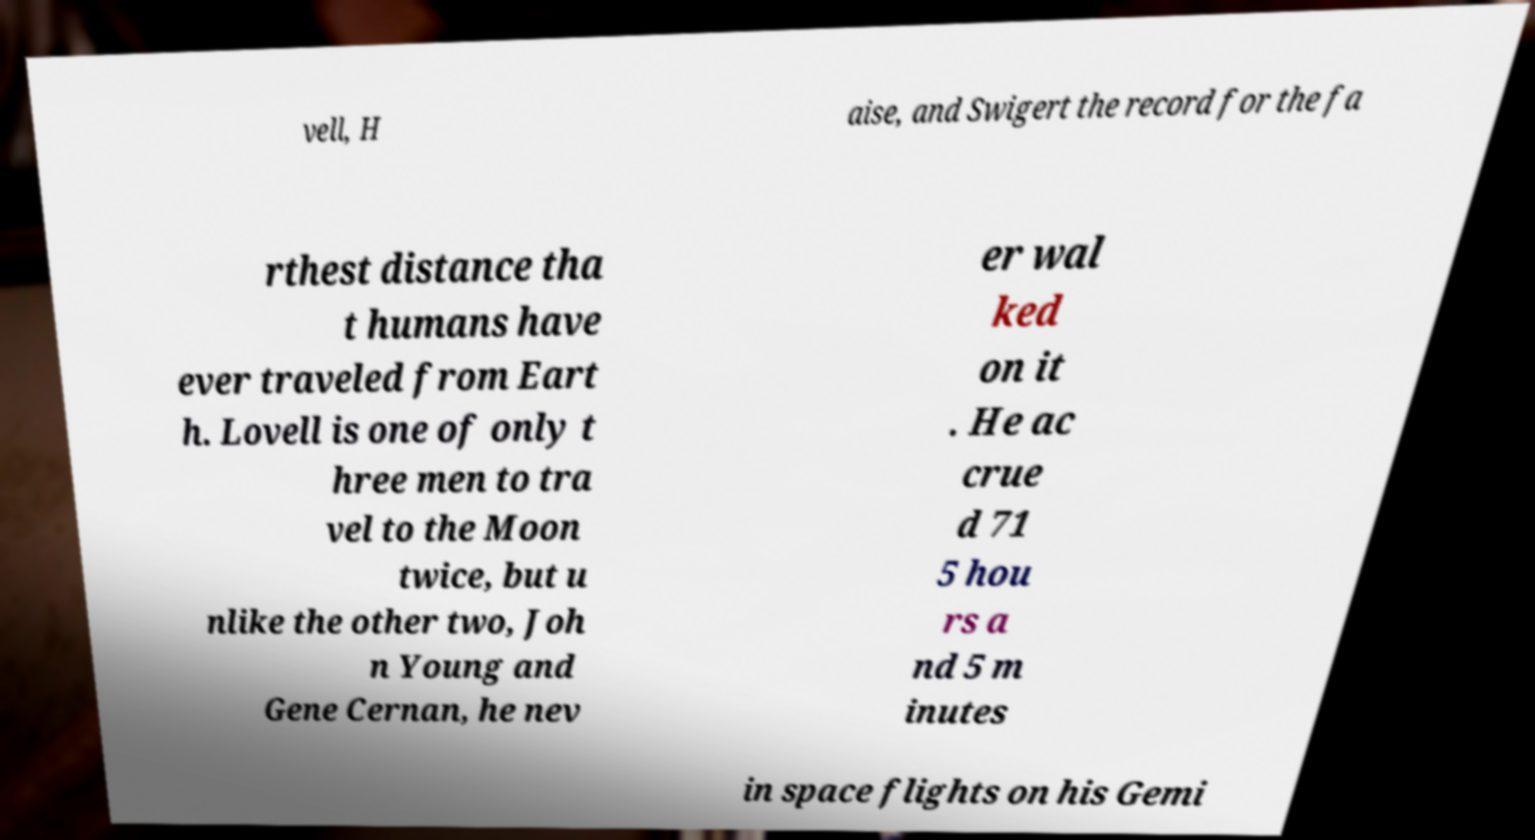For documentation purposes, I need the text within this image transcribed. Could you provide that? vell, H aise, and Swigert the record for the fa rthest distance tha t humans have ever traveled from Eart h. Lovell is one of only t hree men to tra vel to the Moon twice, but u nlike the other two, Joh n Young and Gene Cernan, he nev er wal ked on it . He ac crue d 71 5 hou rs a nd 5 m inutes in space flights on his Gemi 